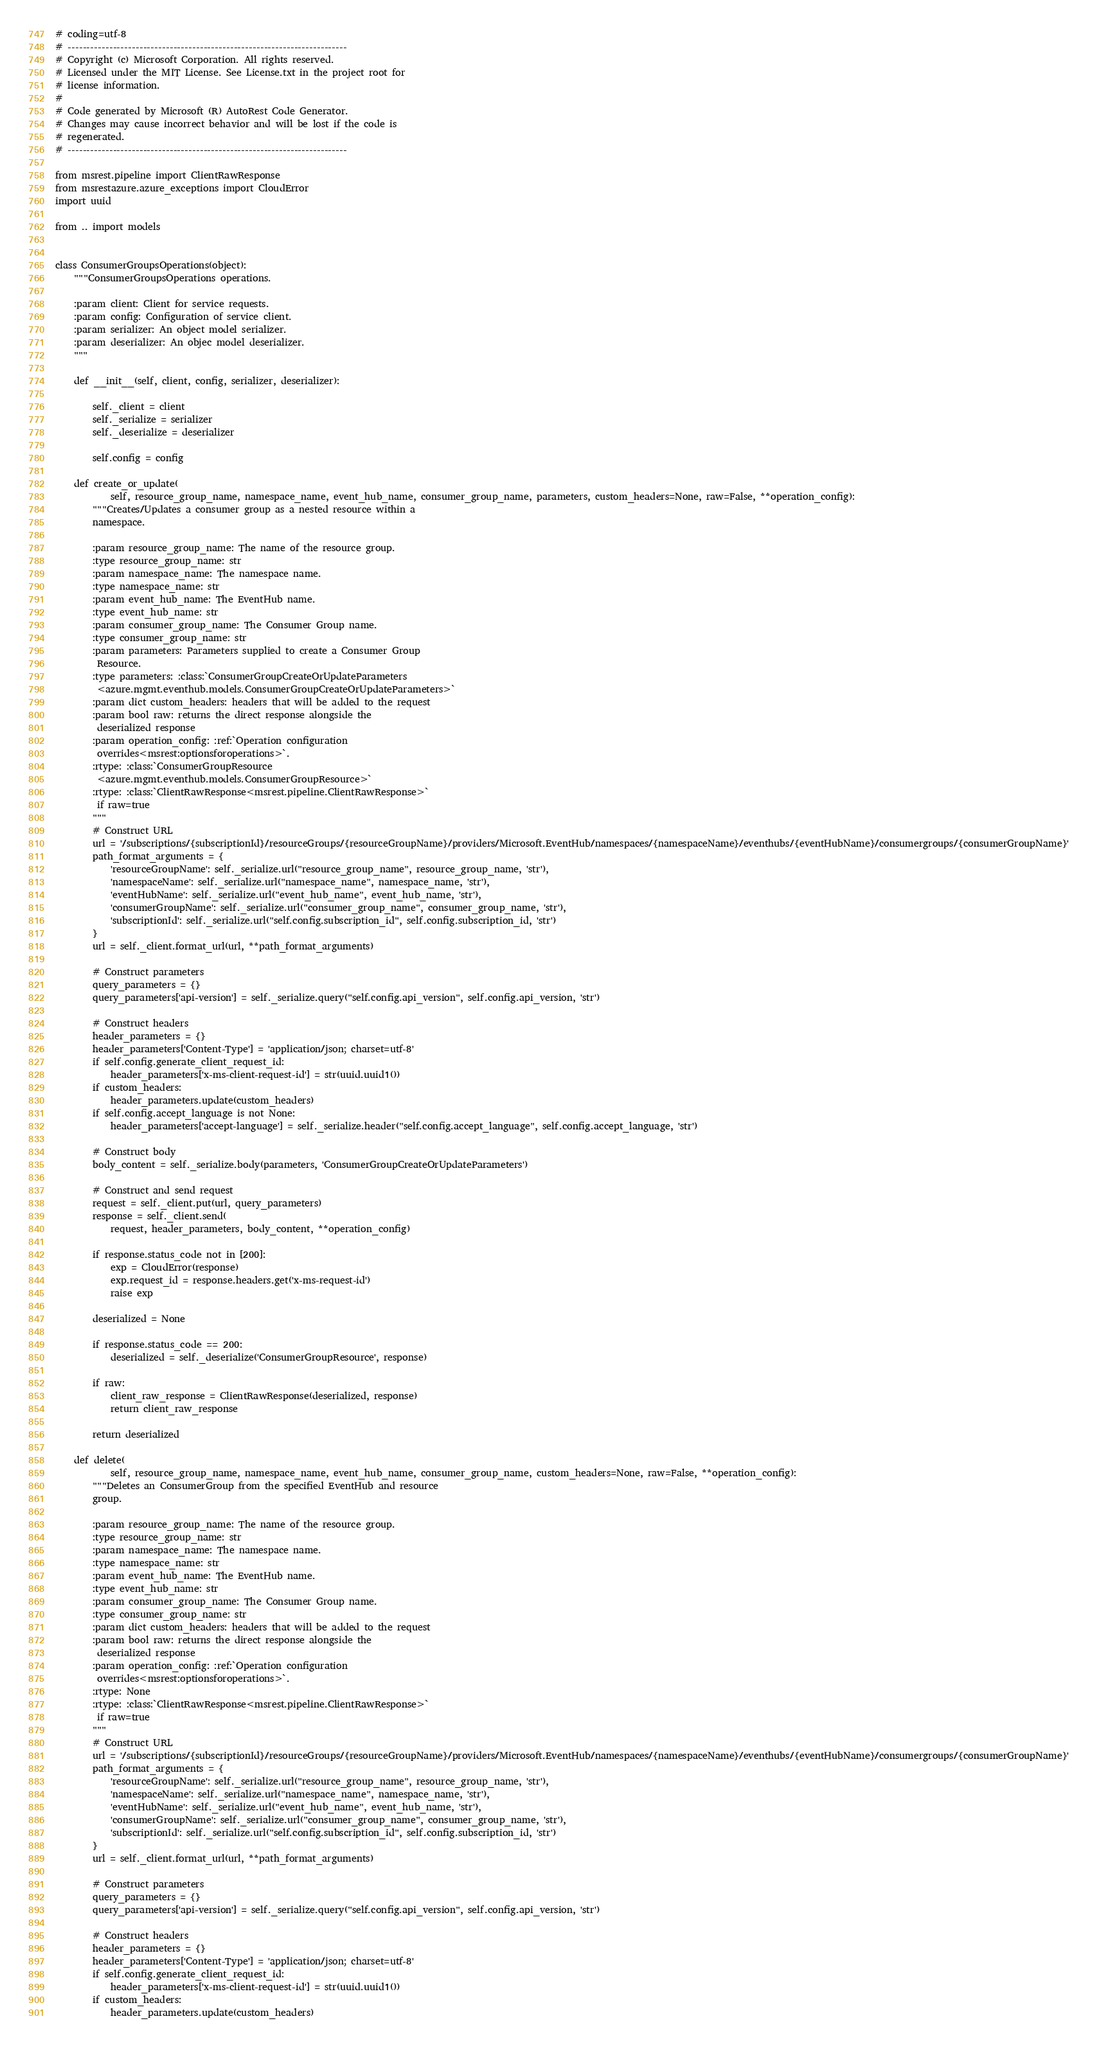Convert code to text. <code><loc_0><loc_0><loc_500><loc_500><_Python_># coding=utf-8
# --------------------------------------------------------------------------
# Copyright (c) Microsoft Corporation. All rights reserved.
# Licensed under the MIT License. See License.txt in the project root for
# license information.
#
# Code generated by Microsoft (R) AutoRest Code Generator.
# Changes may cause incorrect behavior and will be lost if the code is
# regenerated.
# --------------------------------------------------------------------------

from msrest.pipeline import ClientRawResponse
from msrestazure.azure_exceptions import CloudError
import uuid

from .. import models


class ConsumerGroupsOperations(object):
    """ConsumerGroupsOperations operations.

    :param client: Client for service requests.
    :param config: Configuration of service client.
    :param serializer: An object model serializer.
    :param deserializer: An objec model deserializer.
    """

    def __init__(self, client, config, serializer, deserializer):

        self._client = client
        self._serialize = serializer
        self._deserialize = deserializer

        self.config = config

    def create_or_update(
            self, resource_group_name, namespace_name, event_hub_name, consumer_group_name, parameters, custom_headers=None, raw=False, **operation_config):
        """Creates/Updates a consumer group as a nested resource within a
        namespace.

        :param resource_group_name: The name of the resource group.
        :type resource_group_name: str
        :param namespace_name: The namespace name.
        :type namespace_name: str
        :param event_hub_name: The EventHub name.
        :type event_hub_name: str
        :param consumer_group_name: The Consumer Group name.
        :type consumer_group_name: str
        :param parameters: Parameters supplied to create a Consumer Group
         Resource.
        :type parameters: :class:`ConsumerGroupCreateOrUpdateParameters
         <azure.mgmt.eventhub.models.ConsumerGroupCreateOrUpdateParameters>`
        :param dict custom_headers: headers that will be added to the request
        :param bool raw: returns the direct response alongside the
         deserialized response
        :param operation_config: :ref:`Operation configuration
         overrides<msrest:optionsforoperations>`.
        :rtype: :class:`ConsumerGroupResource
         <azure.mgmt.eventhub.models.ConsumerGroupResource>`
        :rtype: :class:`ClientRawResponse<msrest.pipeline.ClientRawResponse>`
         if raw=true
        """
        # Construct URL
        url = '/subscriptions/{subscriptionId}/resourceGroups/{resourceGroupName}/providers/Microsoft.EventHub/namespaces/{namespaceName}/eventhubs/{eventHubName}/consumergroups/{consumerGroupName}'
        path_format_arguments = {
            'resourceGroupName': self._serialize.url("resource_group_name", resource_group_name, 'str'),
            'namespaceName': self._serialize.url("namespace_name", namespace_name, 'str'),
            'eventHubName': self._serialize.url("event_hub_name", event_hub_name, 'str'),
            'consumerGroupName': self._serialize.url("consumer_group_name", consumer_group_name, 'str'),
            'subscriptionId': self._serialize.url("self.config.subscription_id", self.config.subscription_id, 'str')
        }
        url = self._client.format_url(url, **path_format_arguments)

        # Construct parameters
        query_parameters = {}
        query_parameters['api-version'] = self._serialize.query("self.config.api_version", self.config.api_version, 'str')

        # Construct headers
        header_parameters = {}
        header_parameters['Content-Type'] = 'application/json; charset=utf-8'
        if self.config.generate_client_request_id:
            header_parameters['x-ms-client-request-id'] = str(uuid.uuid1())
        if custom_headers:
            header_parameters.update(custom_headers)
        if self.config.accept_language is not None:
            header_parameters['accept-language'] = self._serialize.header("self.config.accept_language", self.config.accept_language, 'str')

        # Construct body
        body_content = self._serialize.body(parameters, 'ConsumerGroupCreateOrUpdateParameters')

        # Construct and send request
        request = self._client.put(url, query_parameters)
        response = self._client.send(
            request, header_parameters, body_content, **operation_config)

        if response.status_code not in [200]:
            exp = CloudError(response)
            exp.request_id = response.headers.get('x-ms-request-id')
            raise exp

        deserialized = None

        if response.status_code == 200:
            deserialized = self._deserialize('ConsumerGroupResource', response)

        if raw:
            client_raw_response = ClientRawResponse(deserialized, response)
            return client_raw_response

        return deserialized

    def delete(
            self, resource_group_name, namespace_name, event_hub_name, consumer_group_name, custom_headers=None, raw=False, **operation_config):
        """Deletes an ConsumerGroup from the specified EventHub and resource
        group.

        :param resource_group_name: The name of the resource group.
        :type resource_group_name: str
        :param namespace_name: The namespace name.
        :type namespace_name: str
        :param event_hub_name: The EventHub name.
        :type event_hub_name: str
        :param consumer_group_name: The Consumer Group name.
        :type consumer_group_name: str
        :param dict custom_headers: headers that will be added to the request
        :param bool raw: returns the direct response alongside the
         deserialized response
        :param operation_config: :ref:`Operation configuration
         overrides<msrest:optionsforoperations>`.
        :rtype: None
        :rtype: :class:`ClientRawResponse<msrest.pipeline.ClientRawResponse>`
         if raw=true
        """
        # Construct URL
        url = '/subscriptions/{subscriptionId}/resourceGroups/{resourceGroupName}/providers/Microsoft.EventHub/namespaces/{namespaceName}/eventhubs/{eventHubName}/consumergroups/{consumerGroupName}'
        path_format_arguments = {
            'resourceGroupName': self._serialize.url("resource_group_name", resource_group_name, 'str'),
            'namespaceName': self._serialize.url("namespace_name", namespace_name, 'str'),
            'eventHubName': self._serialize.url("event_hub_name", event_hub_name, 'str'),
            'consumerGroupName': self._serialize.url("consumer_group_name", consumer_group_name, 'str'),
            'subscriptionId': self._serialize.url("self.config.subscription_id", self.config.subscription_id, 'str')
        }
        url = self._client.format_url(url, **path_format_arguments)

        # Construct parameters
        query_parameters = {}
        query_parameters['api-version'] = self._serialize.query("self.config.api_version", self.config.api_version, 'str')

        # Construct headers
        header_parameters = {}
        header_parameters['Content-Type'] = 'application/json; charset=utf-8'
        if self.config.generate_client_request_id:
            header_parameters['x-ms-client-request-id'] = str(uuid.uuid1())
        if custom_headers:
            header_parameters.update(custom_headers)</code> 